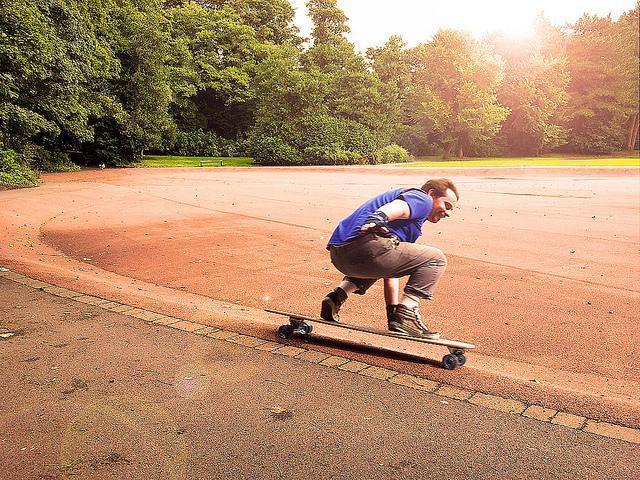How many refrigerators are in this image?
Give a very brief answer. 0. 